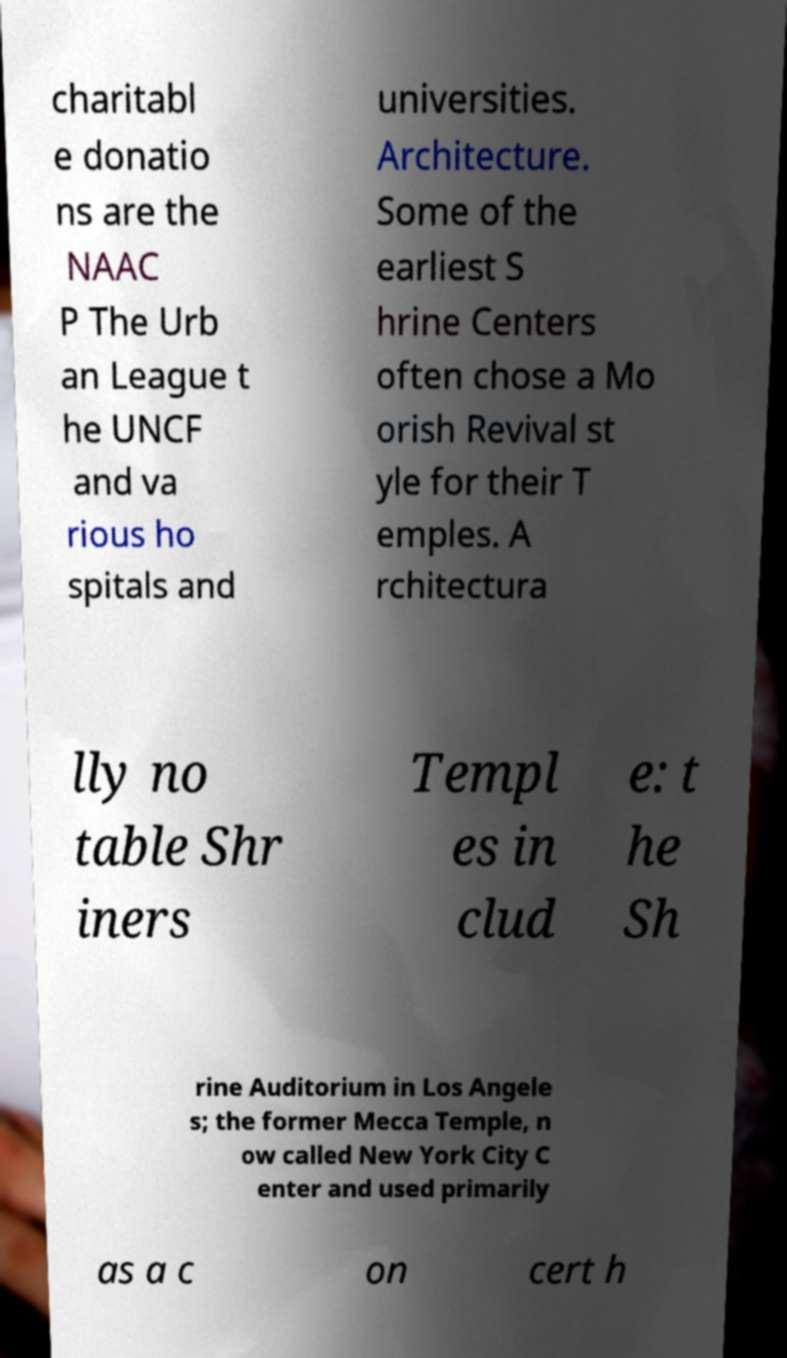Can you accurately transcribe the text from the provided image for me? charitabl e donatio ns are the NAAC P The Urb an League t he UNCF and va rious ho spitals and universities. Architecture. Some of the earliest S hrine Centers often chose a Mo orish Revival st yle for their T emples. A rchitectura lly no table Shr iners Templ es in clud e: t he Sh rine Auditorium in Los Angele s; the former Mecca Temple, n ow called New York City C enter and used primarily as a c on cert h 